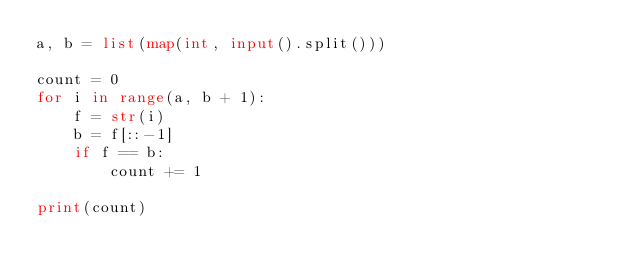Convert code to text. <code><loc_0><loc_0><loc_500><loc_500><_Python_>a, b = list(map(int, input().split()))

count = 0
for i in range(a, b + 1):
    f = str(i)
    b = f[::-1]
    if f == b:
        count += 1

print(count)
</code> 